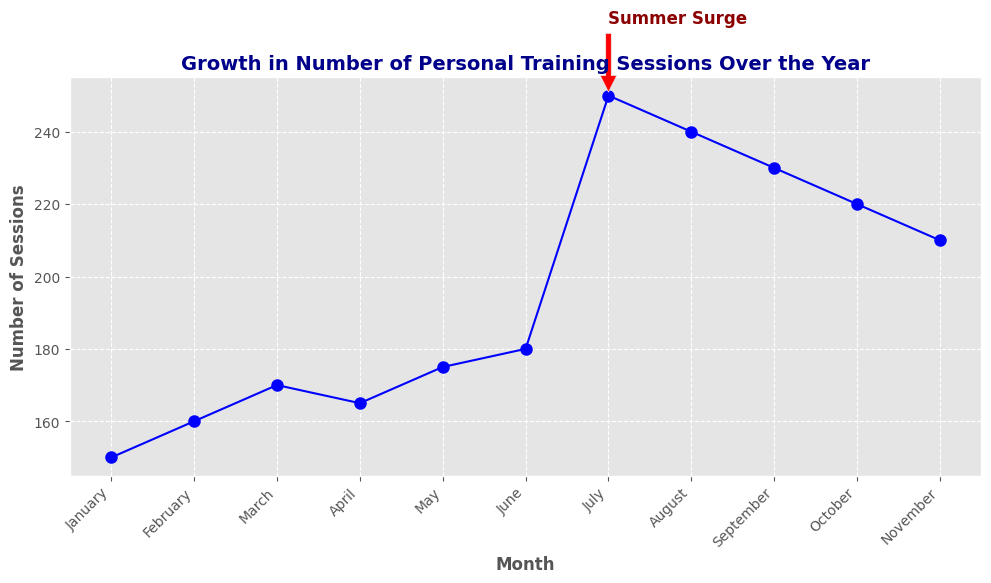How does the number of sessions in July compare to the average number of sessions for the other months? First, sum the number of sessions for January to June and August to November, which are: 150 + 160 + 170 + 165 + 175 + 180 + 240 + 230 + 220 + 210 = 1900. Then, divide by the number of these months, which is 10, so 1900/10 = 190. The number of sessions in July is 250, which is higher than the average (190).
Answer: Higher What is the overall trend in the number of personal training sessions over the year? By observing the line plot, we note the general increase from January to July, peaking in July, followed by a gradual decrease from August to November. This indicates an overall increasing trend up till mid-year, then a declining trend.
Answer: Increasing then decreasing Which month has the highest number of personal training sessions? By inspecting the plot, July shows the highest point on the graph with 250 sessions.
Answer: July Describe the visual attribute that marks the "Summer Surge" annotation. The annotation is marked with a red color and a text label "Summer Surge" placed near the July mark with an arrow pointing upwards.
Answer: Red annotation with arrow Between which two consecutive months is the largest increase in training sessions observed? By examining the plot, the largest vertical increase is between June (180 sessions) and July (250 sessions), which is an increase of 70 sessions.
Answer: June to July What is the difference in the number of sessions between August and September? From the chart, August has 240 sessions, and September has 230 sessions. The difference is 240 - 230 = 10 sessions.
Answer: 10 What is the difference in the number of sessions between the beginning of the year (January) and the end of the year (November)? January has 150 sessions and November has 210 sessions. The difference is calculated as 210 - 150 = 60 sessions.
Answer: 60 What percentage increase is observed from January to July? January has 150 sessions, July has 250 sessions. The increase is 250 - 150 = 100 sessions. The percentage increase is (100/150) * 100 = 66.67%.
Answer: 66.67% Which month shows the first decline in the number of sessions, and by how many sessions did it decrease compared to the previous month? The first decline is observed in April, which has 165 sessions compared to March's 170 sessions. The decrease is 170 - 165 = 5 sessions.
Answer: April, 5 What can be inferred from the pattern between July and November about the fall season’s impact on personal training sessions? Observing the declining trend from 250 sessions in July to 210 sessions in November, it indicates a steady decline, suggesting that the fall season sees a decrease in personal training sessions.
Answer: Decline in sessions 